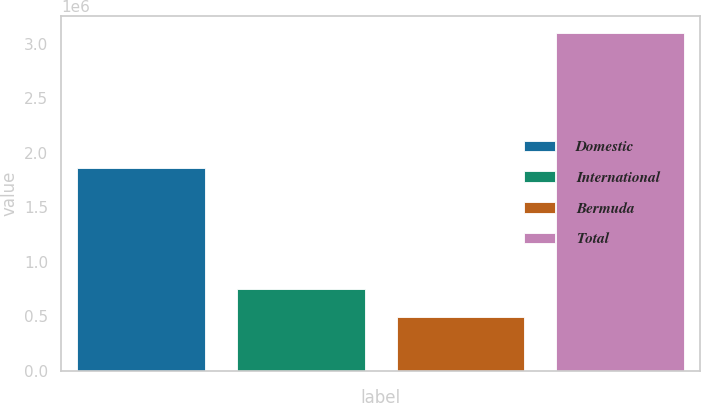<chart> <loc_0><loc_0><loc_500><loc_500><bar_chart><fcel>Domestic<fcel>International<fcel>Bermuda<fcel>Total<nl><fcel>1.85838e+06<fcel>754475<fcel>493648<fcel>3.10192e+06<nl></chart> 